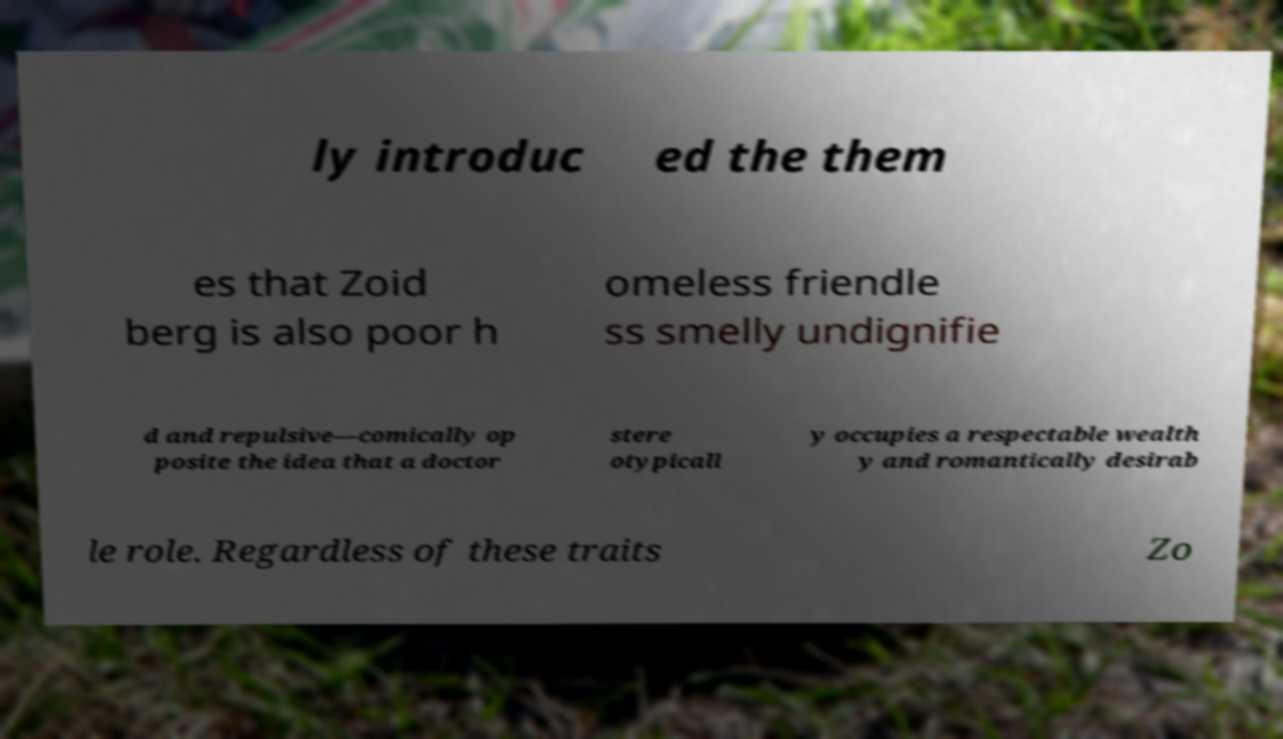There's text embedded in this image that I need extracted. Can you transcribe it verbatim? ly introduc ed the them es that Zoid berg is also poor h omeless friendle ss smelly undignifie d and repulsive—comically op posite the idea that a doctor stere otypicall y occupies a respectable wealth y and romantically desirab le role. Regardless of these traits Zo 